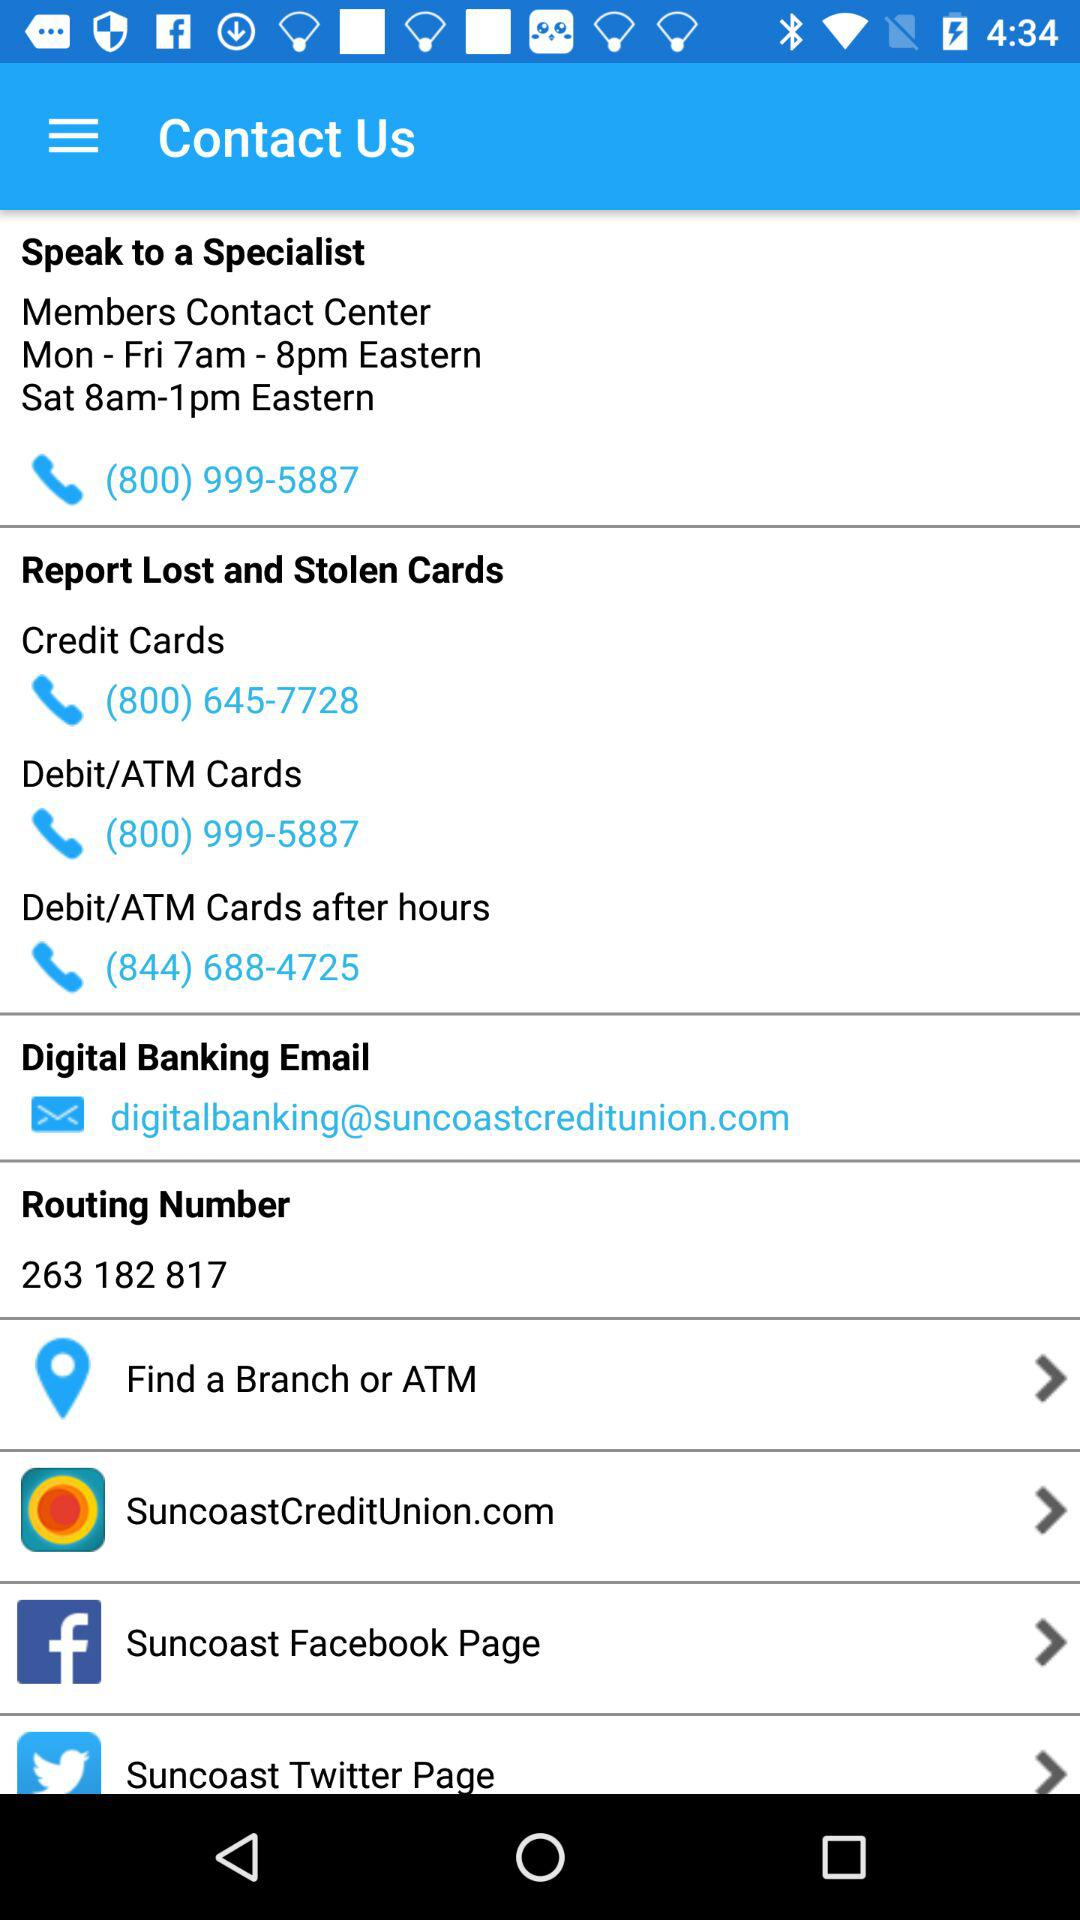What is the phone number of the "Members Contact Center"? The phone number of the "Members Contact Center" is (800) 999-5887. 